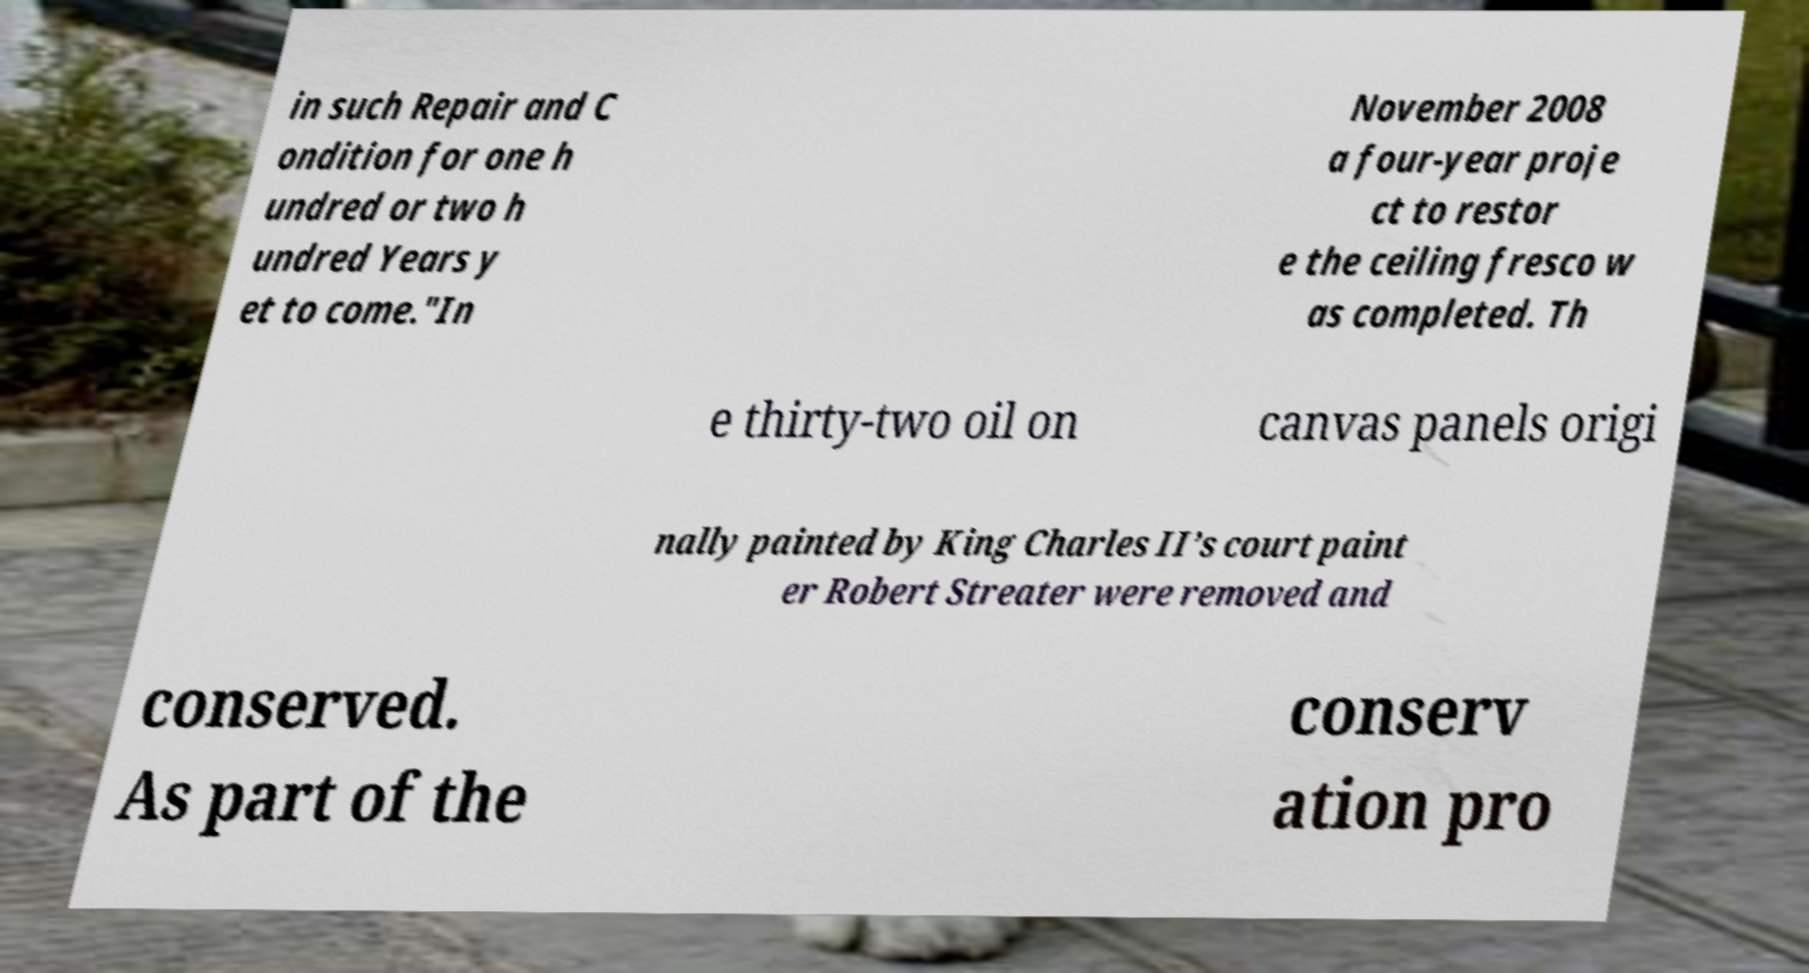Can you read and provide the text displayed in the image?This photo seems to have some interesting text. Can you extract and type it out for me? in such Repair and C ondition for one h undred or two h undred Years y et to come."In November 2008 a four-year proje ct to restor e the ceiling fresco w as completed. Th e thirty-two oil on canvas panels origi nally painted by King Charles II’s court paint er Robert Streater were removed and conserved. As part of the conserv ation pro 